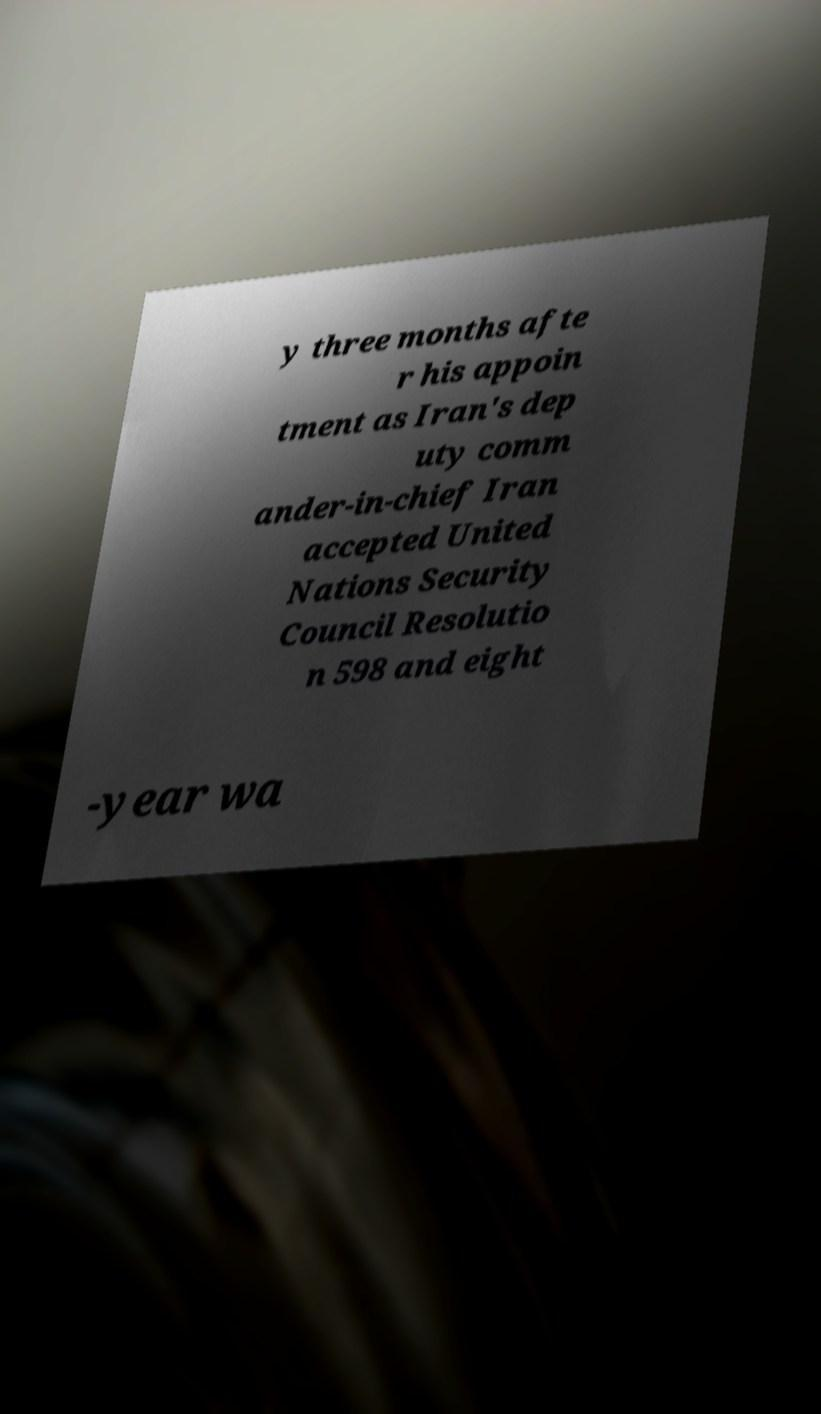Could you extract and type out the text from this image? y three months afte r his appoin tment as Iran's dep uty comm ander-in-chief Iran accepted United Nations Security Council Resolutio n 598 and eight -year wa 